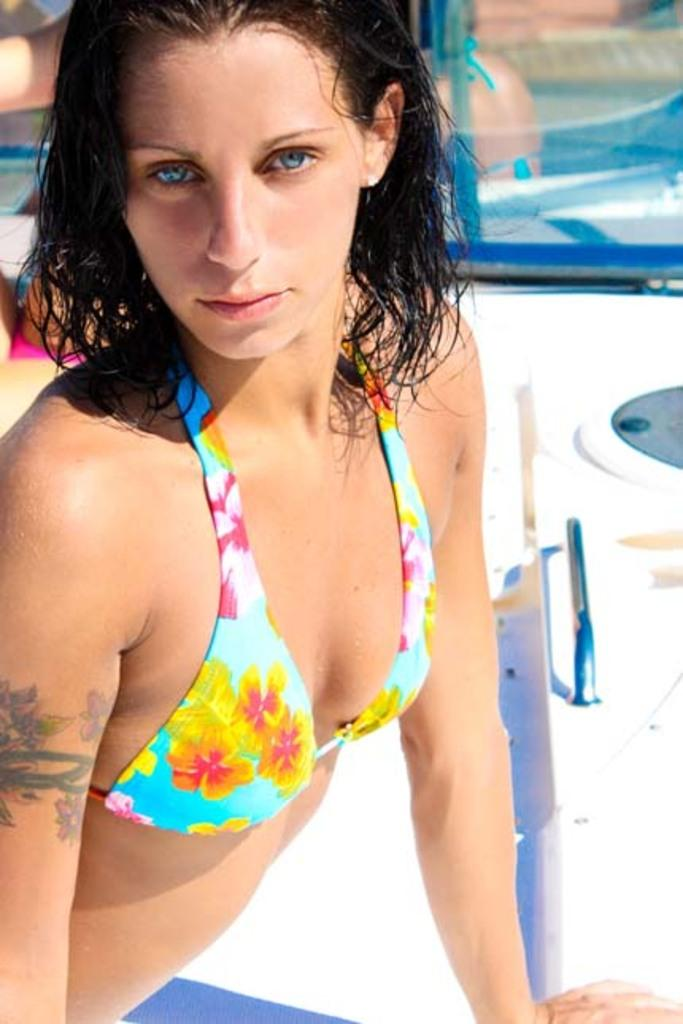Who is present in the image? There is a woman in the image. What can be seen in the background of the image? There is a path visible in the image. What is the woman looking at or observing? The woman is likely looking at or observing the person in the pool, which is visible through the glass. How many geese are present in the image? There are no geese present in the image. What trick is the woman performing in the image? There is no trick being performed in the image; the woman is simply standing and looking at the pool. 